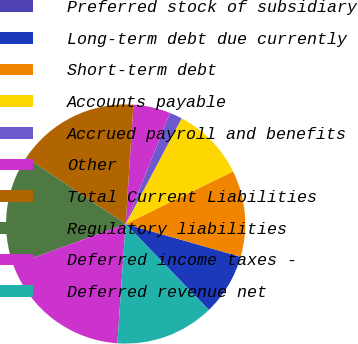Convert chart to OTSL. <chart><loc_0><loc_0><loc_500><loc_500><pie_chart><fcel>Preferred stock of subsidiary<fcel>Long-term debt due currently<fcel>Short-term debt<fcel>Accounts payable<fcel>Accrued payroll and benefits<fcel>Other<fcel>Total Current Liabilities<fcel>Regulatory liabilities<fcel>Deferred income taxes -<fcel>Deferred revenue net<nl><fcel>0.03%<fcel>8.34%<fcel>11.66%<fcel>10.0%<fcel>1.7%<fcel>5.02%<fcel>16.64%<fcel>14.98%<fcel>18.3%<fcel>13.32%<nl></chart> 